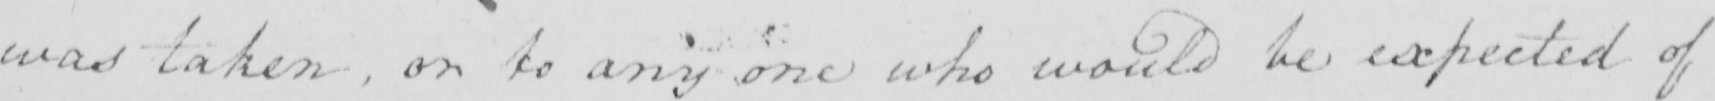Transcribe the text shown in this historical manuscript line. was taken , or to any one who would be expected of 